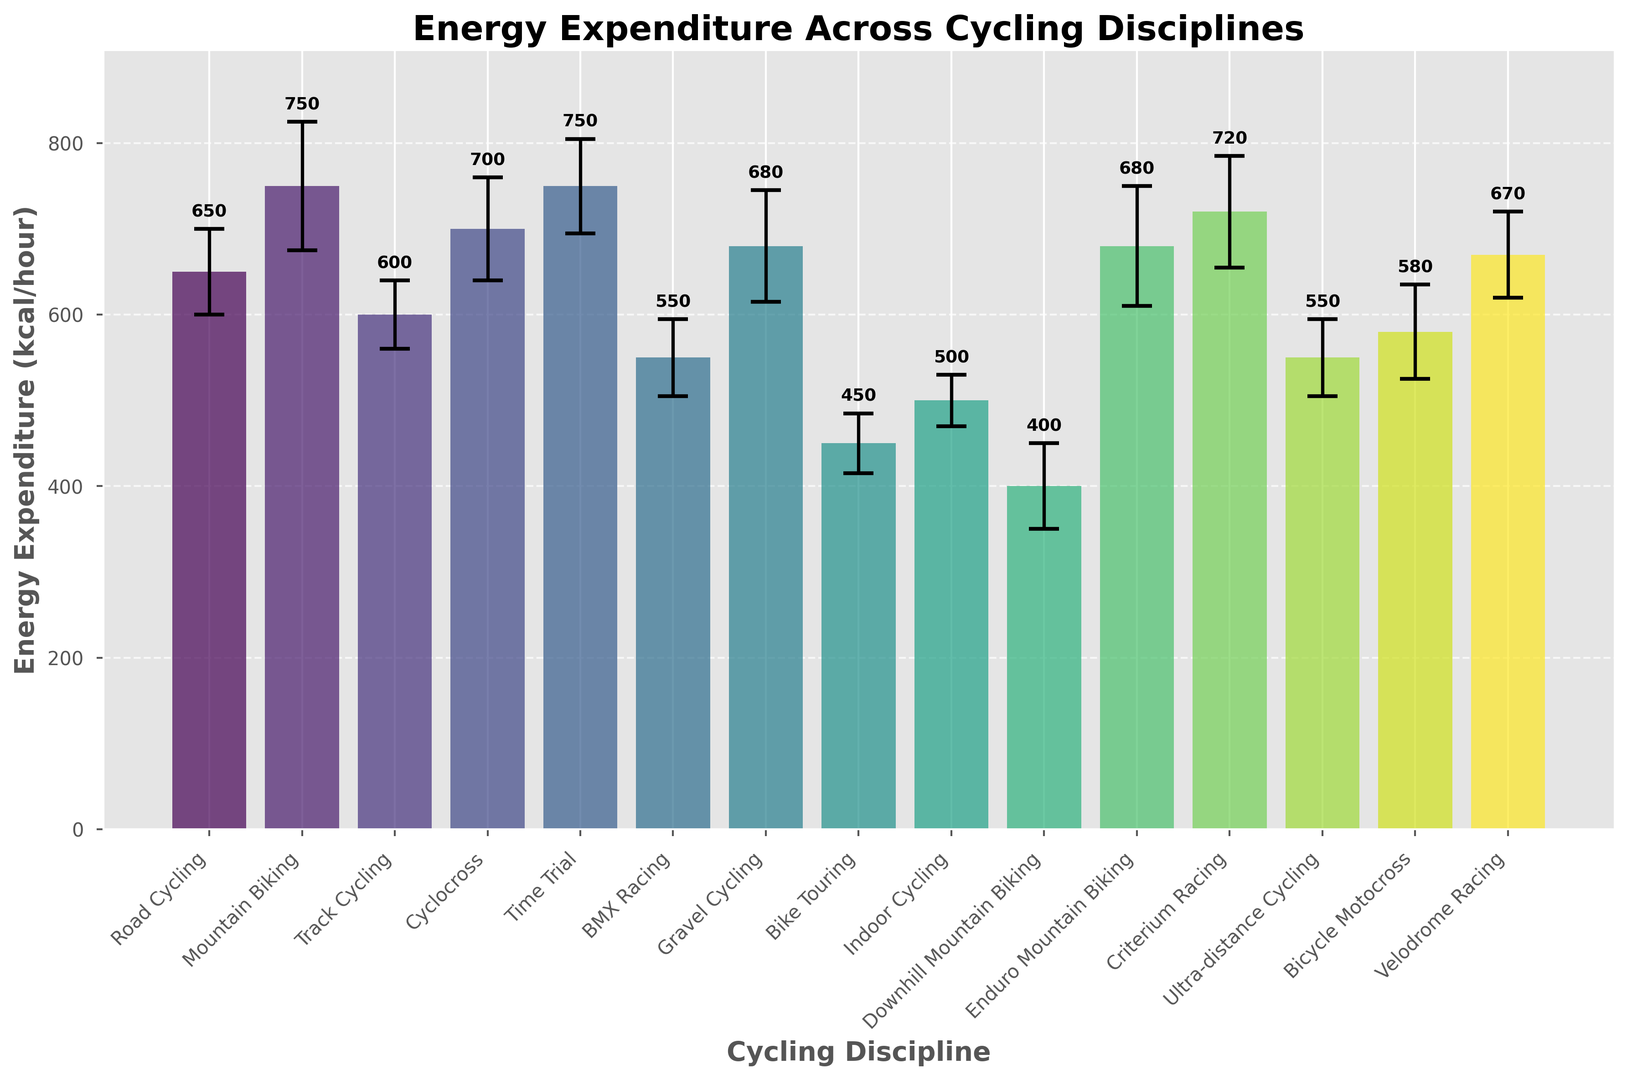Which cycling discipline has the highest average energy expenditure? To identify the discipline, look at the tallest bar on the figure. The Time Trial and Mountain Biking have the tallest bars, both with an average energy expenditure of 750 kcal/hour.
Answer: Time Trial and Mountain Biking Which cycling discipline has the lowest average energy expenditure? Observe the shortest bar on the figure. The Downhill Mountain Biking bar is the shortest, indicating the lowest energy expenditure at 400 kcal/hour.
Answer: Downhill Mountain Biking What is the difference in average energy expenditure between Road Cycling and BMX Racing? Find the bars for Road Cycling and BMX Racing, then subtract BMX Racing's value (550 kcal/hour) from Road Cycling's value (650 kcal/hour). The difference is 650 - 550 = 100 kcal/hour.
Answer: 100 kcal/hour How many cycling disciplines have an average energy expenditure above 700 kcal/hour? Identify and count the bars that exceed the 700 kcal/hour mark. The bars for Mountain Biking, Cyclocross, Time Trial, and Criterium Racing are above this value.
Answer: 4 disciplines Which disciplines have a similar average energy expenditure of about 680 kcal/hour? Look for bars around 680 kcal/hour. Gravel Cycling and Enduro Mountain Biking both have energy expenditures around 680 kcal/hour.
Answer: Gravel Cycling and Enduro Mountain Biking What is the combined energy expenditure of Velodrome Racing and Cyclocross? Add the average energy expenditures of Velodrome Racing (670 kcal/hour) and Cyclocross (700 kcal/hour): 670 + 700 = 1370 kcal/hour.
Answer: 1370 kcal/hour Which cycling discipline has the highest standard deviation, indicating the most variability? The discipline with the largest error bar (vertical line with caps) has the highest standard deviation. Mountain Biking, with a standard deviation of 75 kcal/hour, has the largest error bar.
Answer: Mountain Biking How does the energy expenditure of Bike Touring compare to Indoor Cycling? Compare the heights of the bars for Bike Touring and Indoor Cycling. Bike Touring (450 kcal/hour) has a lower energy expenditure than Indoor Cycling (500 kcal/hour).
Answer: Bike Touring is lower Are there any disciplines with an average energy expenditure of exactly 550 kcal/hour? Check the bars for the exact value of 550 kcal/hour. Both BMX Racing and Ultra-distance Cycling have an average energy expenditure of 550 kcal/hour.
Answer: BMX Racing and Ultra-distance Cycling What is the range of average energy expenditures across all disciplines? Find the difference between the highest and lowest values: The highest is Time Trial and Mountain Biking (750 kcal/hour), and the lowest is Downhill Mountain Biking (400 kcal/hour). The range is 750 - 400 = 350 kcal/hour.
Answer: 350 kcal/hour 